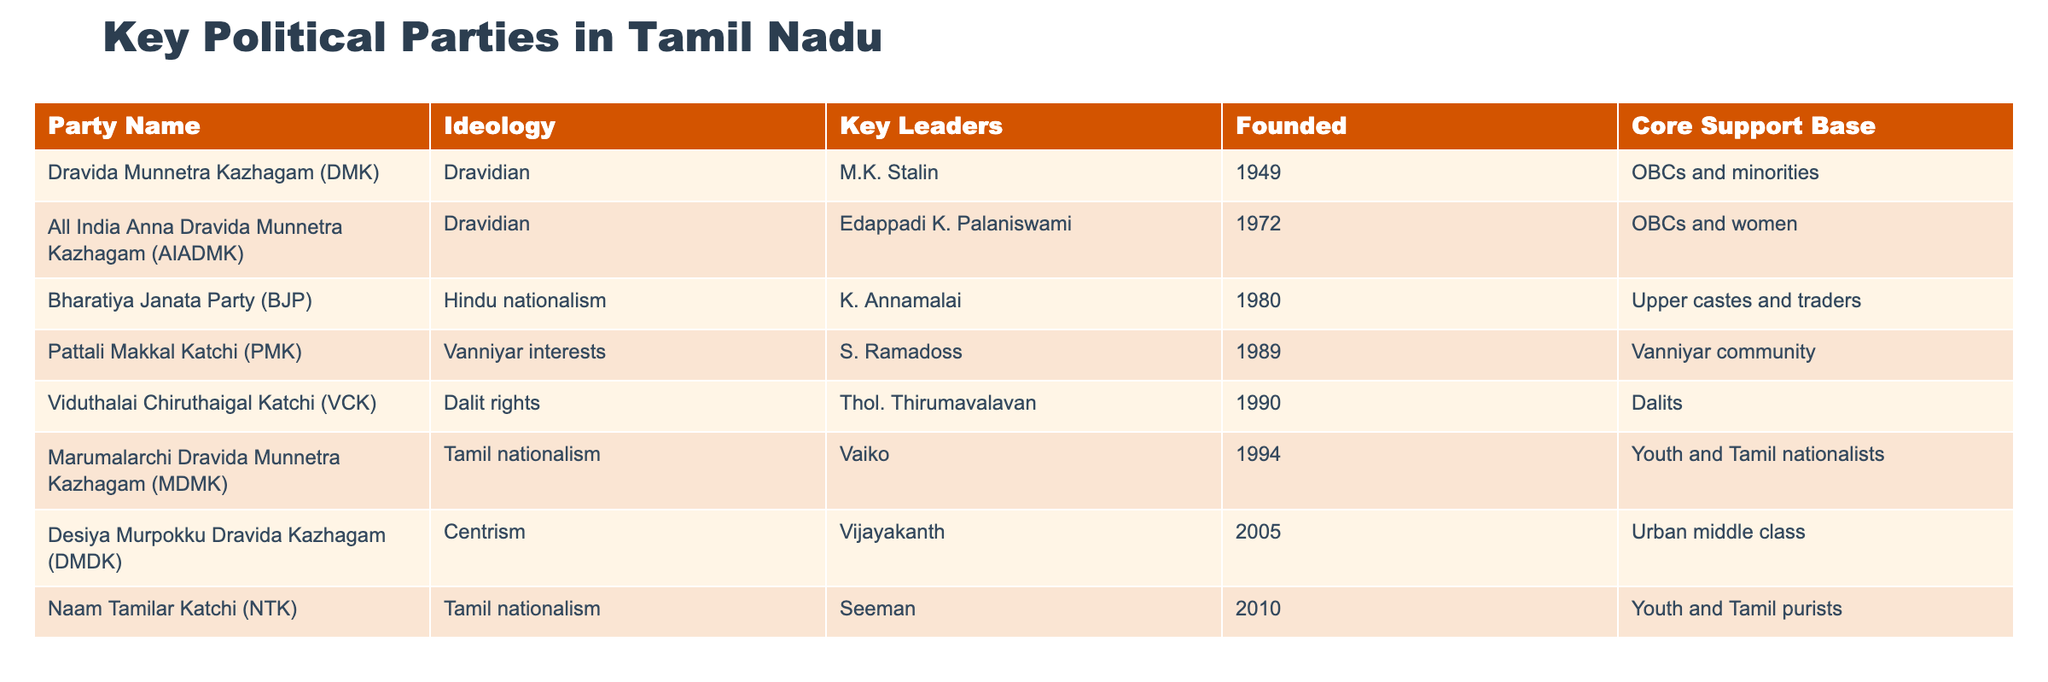What is the ideology of the Dravida Munnetra Kazhagam (DMK)? According to the table, the ideology of the Dravida Munnetra Kazhagam (DMK) is listed as "Dravidian."
Answer: Dravidian Who is the key leader of the All India Anna Dravida Munnetra Kazhagam (AIADMK)? The table states that the key leader of AIADMK is Edappadi K. Palaniswami.
Answer: Edappadi K. Palaniswami How many parties were founded before 1990? The parties founded before 1990 include DMK (1949), AIADMK (1972), BJP (1980), PMK (1989), making it a total of 4 parties.
Answer: 4 Does the Bharatiya Janata Party (BJP) have a core support base among minorities? The table shows that BJP's core support base is among upper castes and traders, which indicates minorities are not part of its primary support base.
Answer: No What is the common ideological theme of DMK, AIADMK, and PMK? All three parties are associated with Dravidian ideologies (DMK and AIADMK are Dravidian, while PMK focuses on Vanniyar interests, which rests on a broader Dravidian context); hence, they share the Dravidian ideology as a common theme.
Answer: Dravidian Which party was founded most recently and what is its ideology? The table shows that the most recently founded party is Naam Tamilar Katchi (NTK), established in 2010, and its ideology is Tamil nationalism.
Answer: Tamil nationalism What percentage of the listed parties focus on Tamil nationalism or Dravidian ideologies? There are 5 parties (DMK, AIADMK, PMK, MDMK, NTK) out of 8 total that align with Dravidian or Tamil nationalism ideologies. This represents about 62.5% (5 out of 8).
Answer: 62.5% Is Thol. Thirumavalavan a leader of a party that focuses on Dalit rights? The table indicates that Thol. Thirumavalavan is indeed the leader of the Viduthalai Chiruthaigal Katchi (VCK), which is dedicated to Dalit rights.
Answer: Yes What is the core support base of the Desiya Murpokku Dravida Kazhagam (DMDK)? DMDK's core support base, according to the table, is identified as the urban middle class.
Answer: Urban middle class 